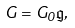Convert formula to latex. <formula><loc_0><loc_0><loc_500><loc_500>G = G _ { 0 } \mathfrak { g } ,</formula> 